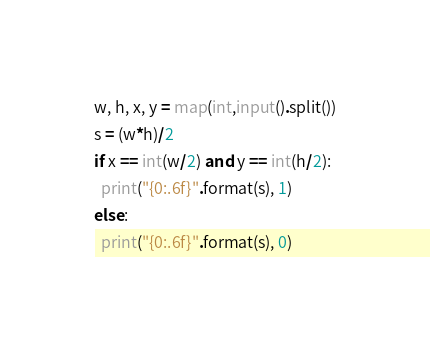<code> <loc_0><loc_0><loc_500><loc_500><_Python_>w, h, x, y = map(int,input().split())
s = (w*h)/2
if x == int(w/2) and y == int(h/2):
  print("{0:.6f}".format(s), 1)
else:
  print("{0:.6f}".format(s), 0)</code> 